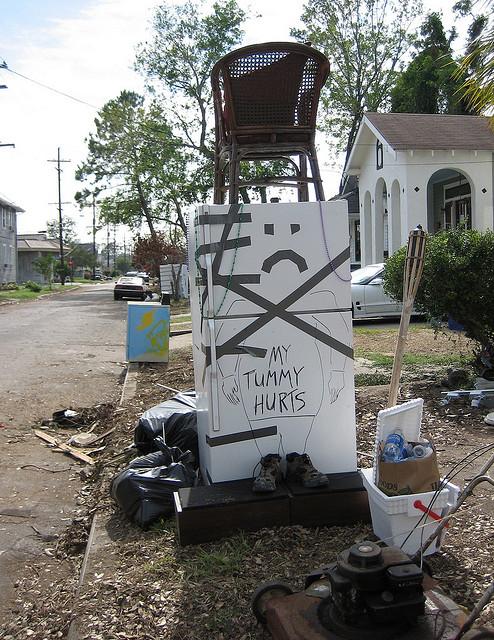What does the post sign?
Short answer required. My tummy hurts. What is on top of the refrigerator?
Be succinct. Chair. What is the color of the grass?
Give a very brief answer. Brown. What color is the house?
Quick response, please. White. 